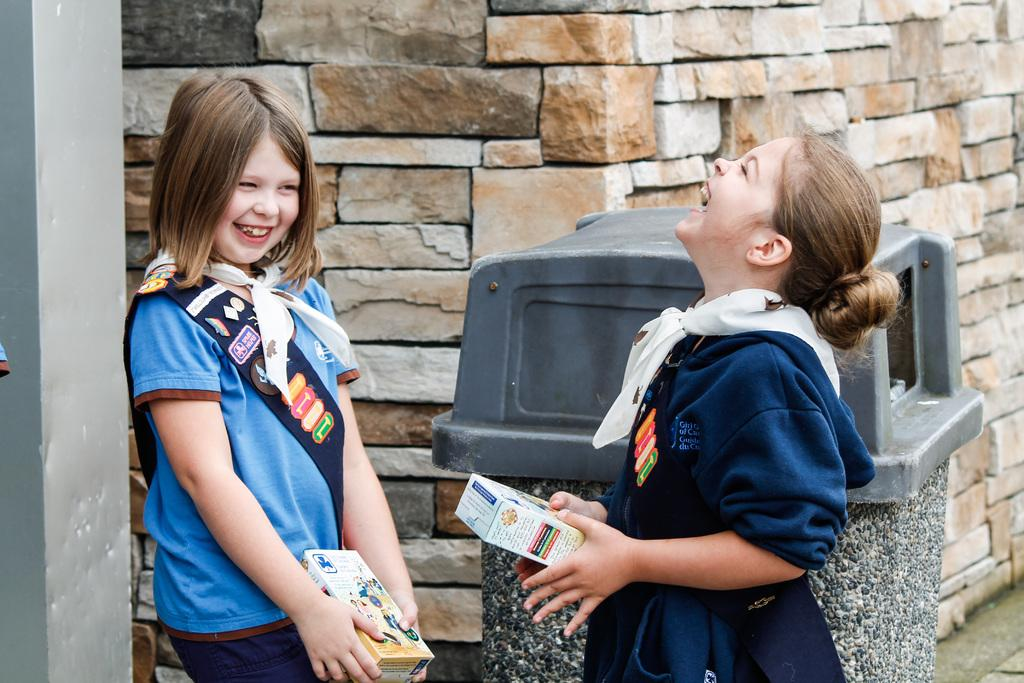How many girls are in the image? There are two girls in the image. What are the girls holding in their hands? The girls are holding something in their hands, but the specific object is not mentioned in the facts. What is the emotional state of the girls in the image? The girls are laughing in the image. Can you describe the background of the image? There is garbage behind one of the girls. What colors are the girls wearing in the image? Both girls are wearing blue color dresses and white color scarves. Is there a volcano erupting in the background of the image? No, there is no volcano present in the image. Are the girls playing basketball in the image? No, there is no basketball or any indication of a basketball game in the image. 